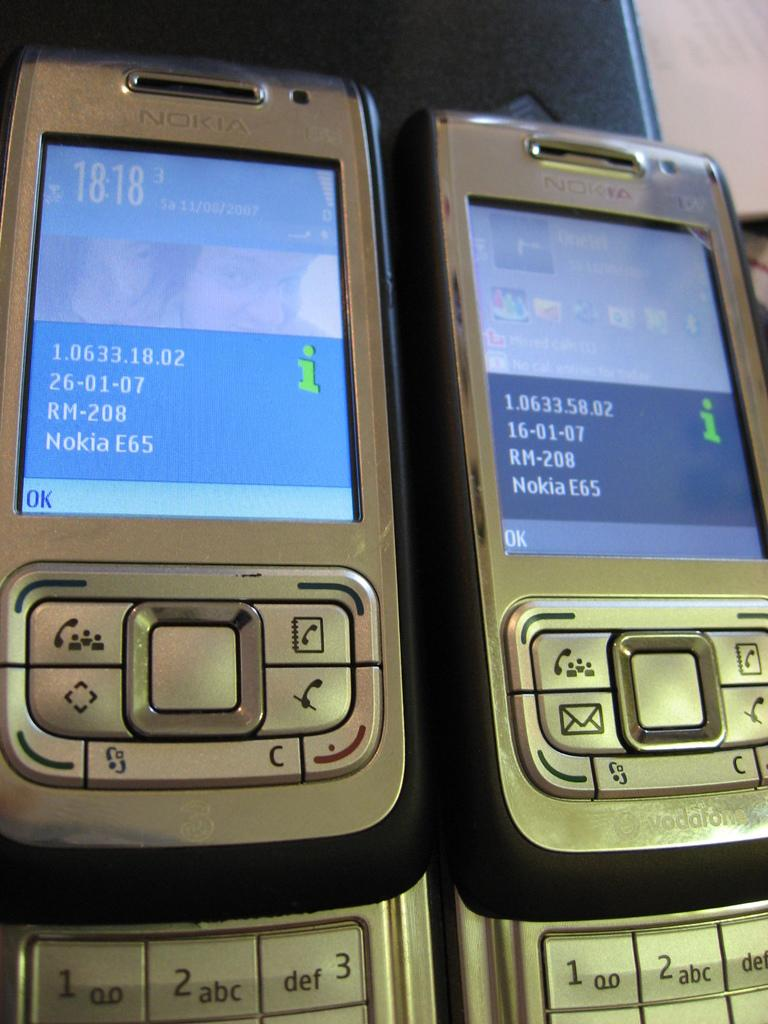<image>
Present a compact description of the photo's key features. Two Nokia phones sitting side by side with the displays on. 